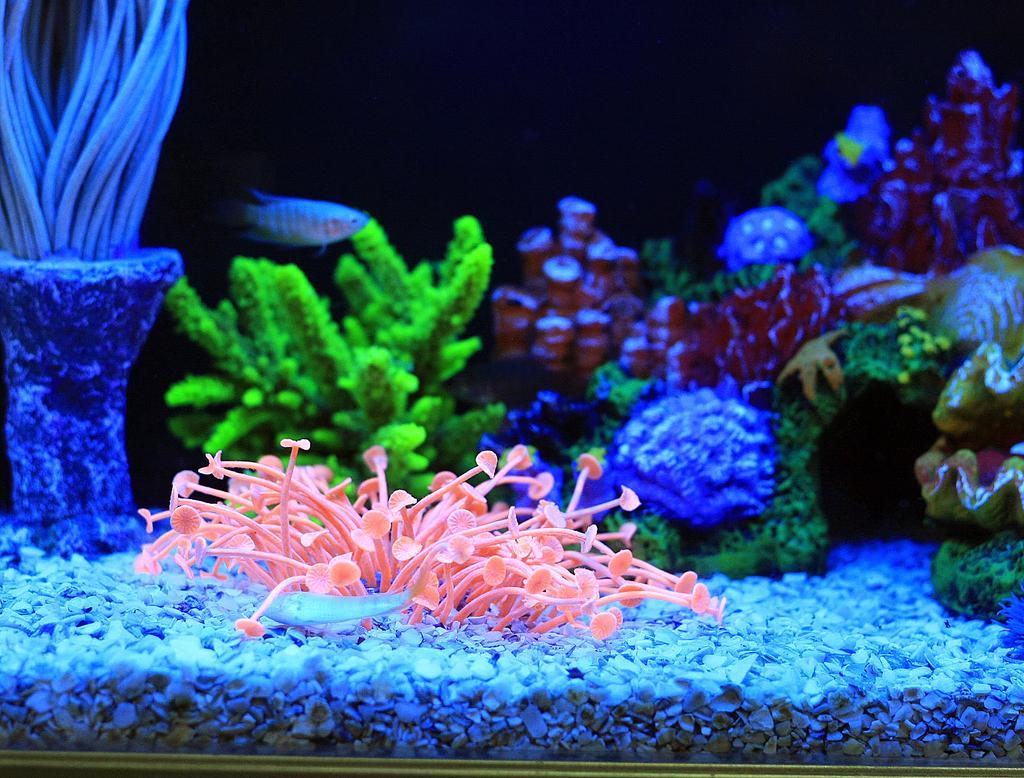How would you summarize this image in a sentence or two? In this image I can see an aquarium. In the aquarium I can see many aquatic plants, few fish and the stones. And there is a black background. 